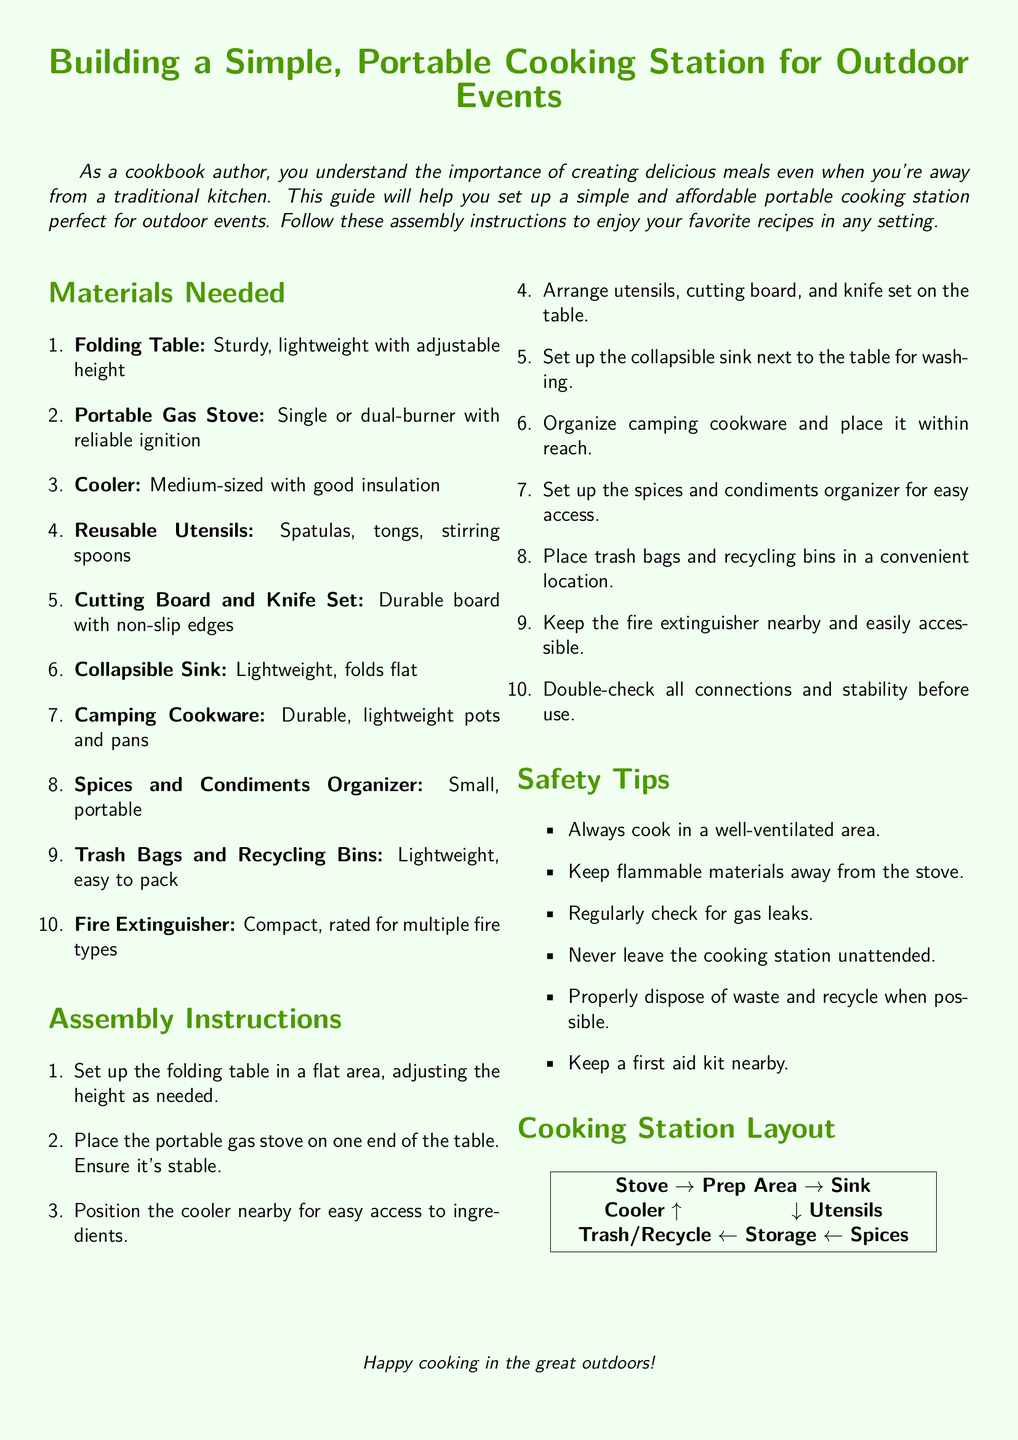what is the main title of the document? The main title, displayed prominently at the top, outlines the subject matter of the document.
Answer: Building a Simple, Portable Cooking Station for Outdoor Events how many materials are listed in the document? The number of items is specified in the "Materials Needed" section of the document.
Answer: 10 what is the first item in the materials list? The first item is identified in the "Materials Needed" section as it appears at the top of the list.
Answer: Folding Table name one safety tip mentioned in the document. Safety tips are listed in their own section, and any listed tip can be an acceptable answer.
Answer: Cook in a well-ventilated area where should the fire extinguisher be placed? The placement of the fire extinguisher is specified in the "Assembly Instructions" for safety.
Answer: Nearby what is the layout of the cooking station described in the document? The layout is visually summarized in the "Cooking Station Layout" section and the arrangement of items provides a clear idea.
Answer: Stove → Prep Area → Sink how is the cooler positioned relative to the stove? The relationship between these two items is described in the layout, indicating their proximity to one another.
Answer: Nearby what type of stove is recommended in the materials needed section? The specific recommendations for the stove's features are described.
Answer: Portable Gas Stove what should be done with trash and recycling? The document provides instructions regarding waste management, indicating what actions to take.
Answer: Properly dispose of waste and recycle when possible 